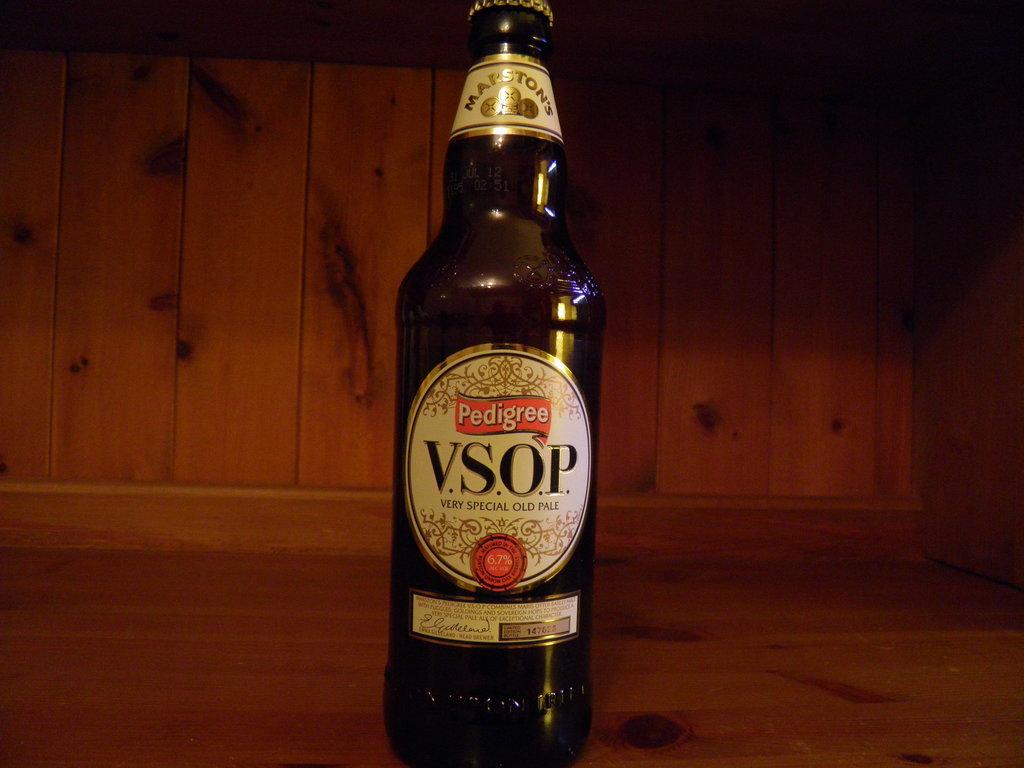Whats 4 letters are the name of this bottle?
Make the answer very short. Vsop. 